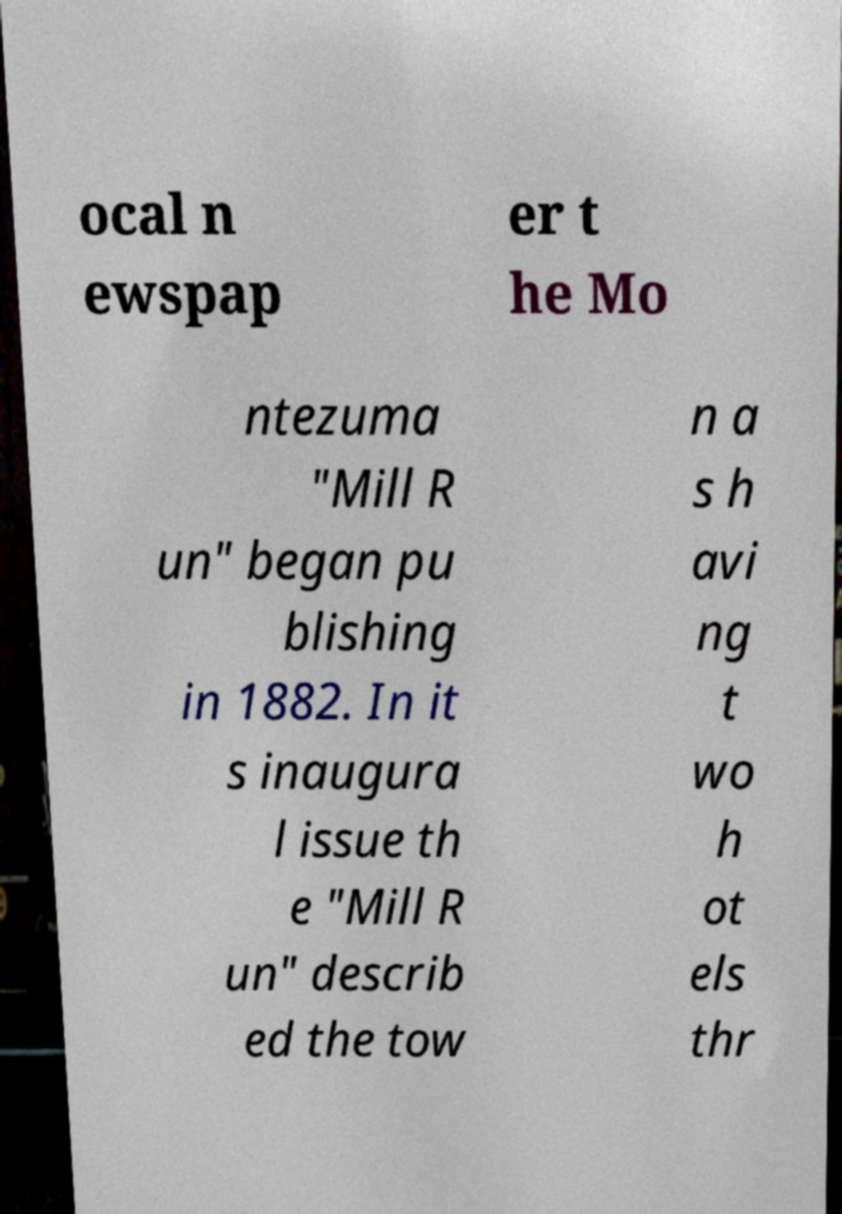For documentation purposes, I need the text within this image transcribed. Could you provide that? ocal n ewspap er t he Mo ntezuma "Mill R un" began pu blishing in 1882. In it s inaugura l issue th e "Mill R un" describ ed the tow n a s h avi ng t wo h ot els thr 